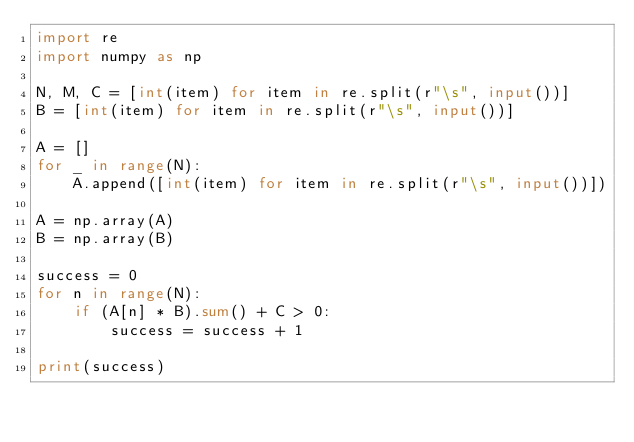<code> <loc_0><loc_0><loc_500><loc_500><_Python_>import re
import numpy as np

N, M, C = [int(item) for item in re.split(r"\s", input())]
B = [int(item) for item in re.split(r"\s", input())]

A = []
for _ in range(N):
    A.append([int(item) for item in re.split(r"\s", input())])

A = np.array(A)
B = np.array(B)

success = 0
for n in range(N):
    if (A[n] * B).sum() + C > 0:
        success = success + 1

print(success)
</code> 